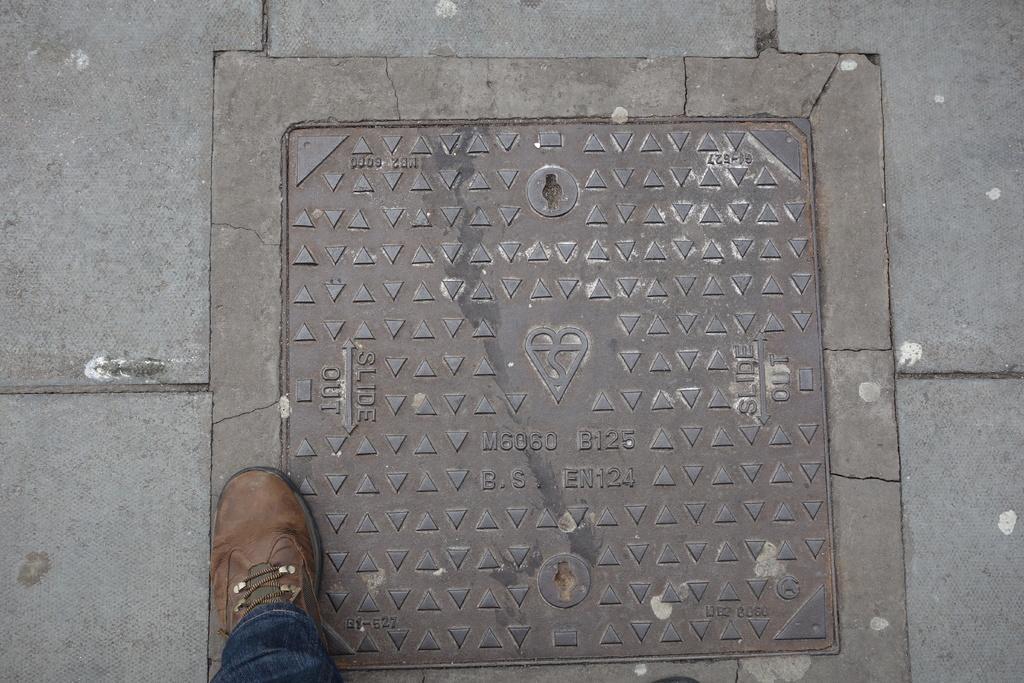Can you describe this image briefly? in this image there is a shoe at bottom of this image and there is a steel plate attached to the floor as we can see in middle of this image. 